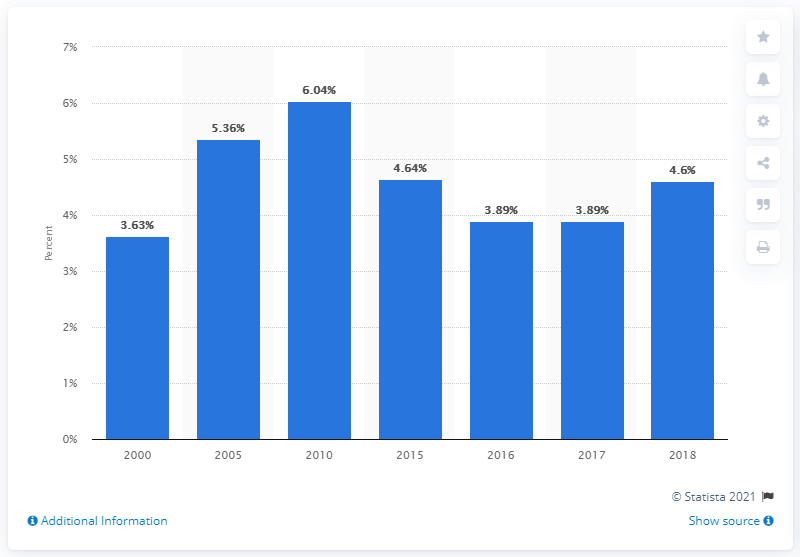Highlight a few significant elements in this photo. In 2018, the Earning Price Ratio of the S&P 500 composite index was 4.6. 